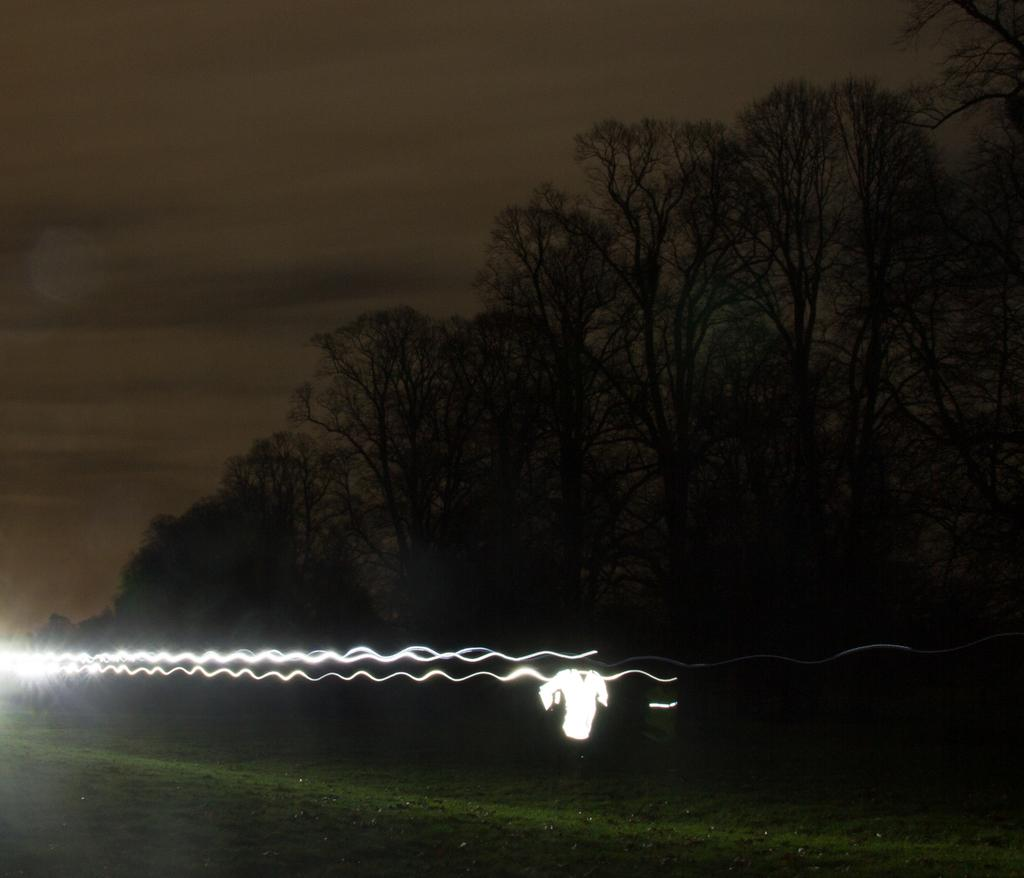What is attached to the fencing in the image? There are lights on the fencing in the image. What can be seen near the fencing in the image? There are trees near the fencing in the image. What type of division can be seen between the trees in the image? There is no division between the trees mentioned in the image. What color is the rose on the fencing in the image? There is no rose present on the fencing in the image. 